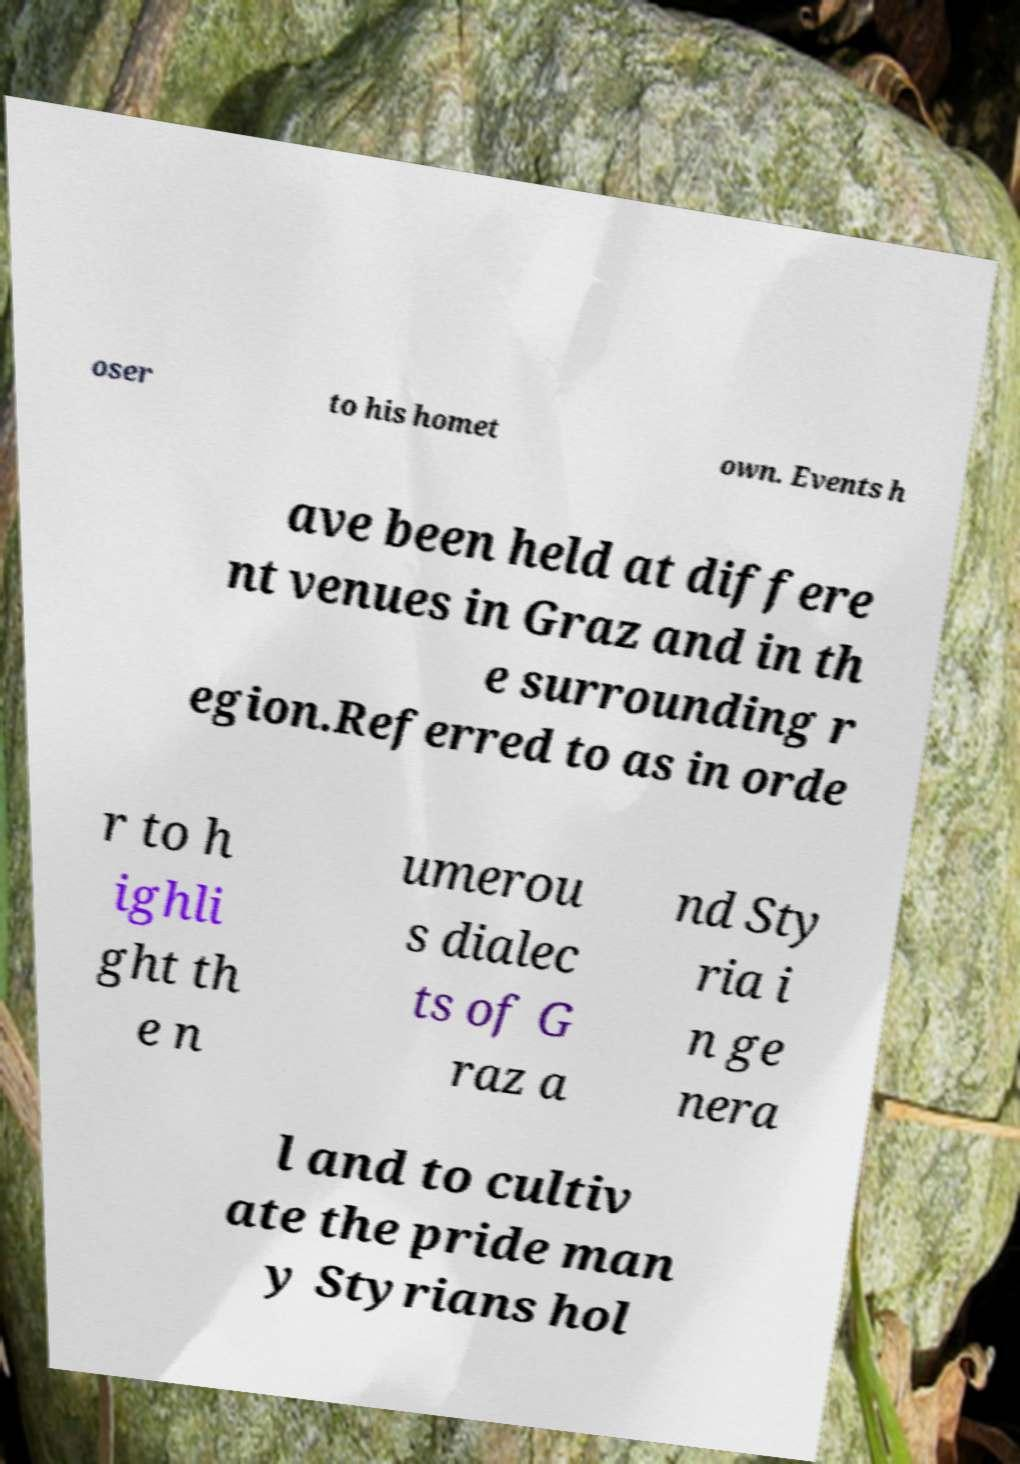I need the written content from this picture converted into text. Can you do that? oser to his homet own. Events h ave been held at differe nt venues in Graz and in th e surrounding r egion.Referred to as in orde r to h ighli ght th e n umerou s dialec ts of G raz a nd Sty ria i n ge nera l and to cultiv ate the pride man y Styrians hol 